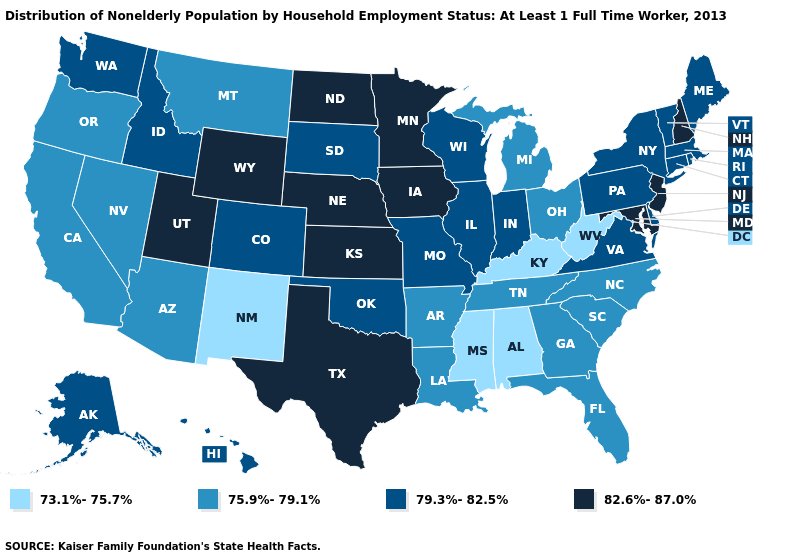What is the lowest value in the USA?
Give a very brief answer. 73.1%-75.7%. Name the states that have a value in the range 79.3%-82.5%?
Give a very brief answer. Alaska, Colorado, Connecticut, Delaware, Hawaii, Idaho, Illinois, Indiana, Maine, Massachusetts, Missouri, New York, Oklahoma, Pennsylvania, Rhode Island, South Dakota, Vermont, Virginia, Washington, Wisconsin. Which states have the highest value in the USA?
Quick response, please. Iowa, Kansas, Maryland, Minnesota, Nebraska, New Hampshire, New Jersey, North Dakota, Texas, Utah, Wyoming. What is the highest value in the West ?
Be succinct. 82.6%-87.0%. What is the value of South Dakota?
Keep it brief. 79.3%-82.5%. Name the states that have a value in the range 73.1%-75.7%?
Be succinct. Alabama, Kentucky, Mississippi, New Mexico, West Virginia. Does Virginia have a lower value than Wyoming?
Quick response, please. Yes. Does Montana have a lower value than Louisiana?
Quick response, please. No. Does California have the same value as Michigan?
Be succinct. Yes. Among the states that border Delaware , does Pennsylvania have the highest value?
Be succinct. No. Name the states that have a value in the range 82.6%-87.0%?
Give a very brief answer. Iowa, Kansas, Maryland, Minnesota, Nebraska, New Hampshire, New Jersey, North Dakota, Texas, Utah, Wyoming. Does Georgia have the same value as Vermont?
Quick response, please. No. Which states have the highest value in the USA?
Concise answer only. Iowa, Kansas, Maryland, Minnesota, Nebraska, New Hampshire, New Jersey, North Dakota, Texas, Utah, Wyoming. Among the states that border Iowa , which have the lowest value?
Answer briefly. Illinois, Missouri, South Dakota, Wisconsin. Does Indiana have the highest value in the USA?
Short answer required. No. 